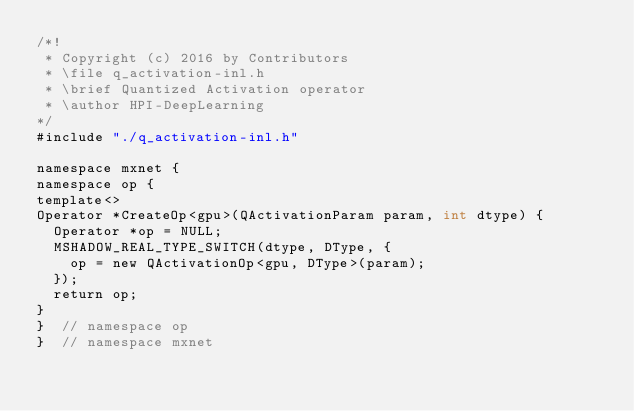Convert code to text. <code><loc_0><loc_0><loc_500><loc_500><_Cuda_>/*!
 * Copyright (c) 2016 by Contributors
 * \file q_activation-inl.h
 * \brief Quantized Activation operator
 * \author HPI-DeepLearning
*/
#include "./q_activation-inl.h"

namespace mxnet {
namespace op {
template<>
Operator *CreateOp<gpu>(QActivationParam param, int dtype) {
  Operator *op = NULL;
  MSHADOW_REAL_TYPE_SWITCH(dtype, DType, {
    op = new QActivationOp<gpu, DType>(param);
  });
  return op;
}
}  // namespace op
}  // namespace mxnet

</code> 